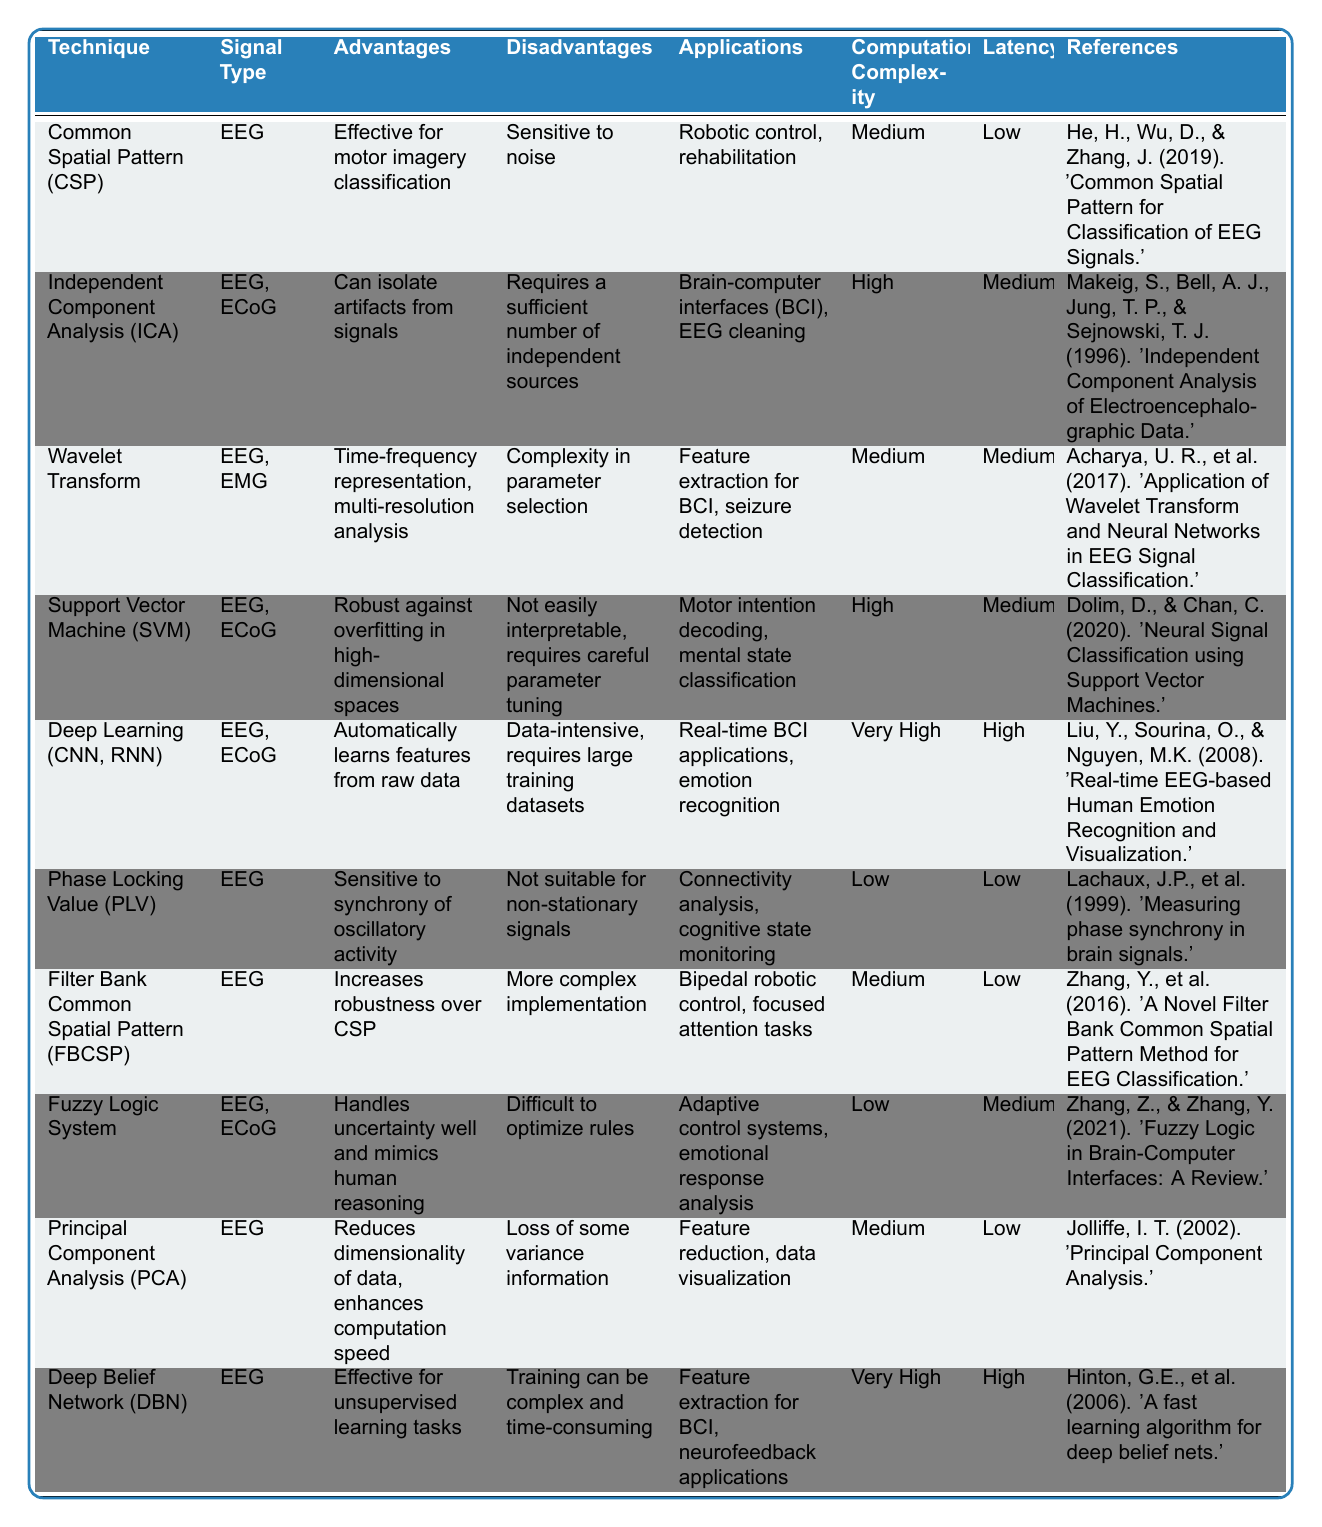What technique is effective for motor imagery classification? The table lists the "Common Spatial Pattern (CSP)" under the Advantages column for its effectiveness in motor imagery classification.
Answer: Common Spatial Pattern (CSP) Which technique has the lowest computational complexity? The table shows that "Phase Locking Value (PLV)" and "Fuzzy Logic System" are the techniques with the lowest computational complexity, both listed as Low.
Answer: Phase Locking Value (PLV), Fuzzy Logic System Is the Independent Component Analysis (ICA) suitable for EEG signals only? The table indicates that ICA can process both EEG and ECoG signal types, so it is not limited to EEG signals only.
Answer: No What are the applications of the Deep Learning technique? According to the table, Deep Learning techniques are used in real-time BCI applications and emotion recognition.
Answer: Real-time BCI applications, emotion recognition Which techniques have low latency? The table lists the techniques with low latency as Common Spatial Pattern (CSP), Phase Locking Value (PLV), Filter Bank Common Spatial Pattern (FBCSP), and Principal Component Analysis (PCA).
Answer: Common Spatial Pattern (CSP), Phase Locking Value (PLV), Filter Bank Common Spatial Pattern (FBCSP), Principal Component Analysis (PCA) Which two techniques have very high computational complexity? The table specifies that the techniques with very high computational complexity are Deep Learning and Deep Belief Network (DBN).
Answer: Deep Learning, Deep Belief Network (DBN) What is the main disadvantage of using Deep Learning techniques? The table states that the main disadvantage of Deep Learning techniques is that they are data-intensive and require large training datasets, which may hinder their application.
Answer: Data-intensive, requires large training datasets Compare the latency of Wavelet Transform and Support Vector Machine (SVM). The latency for Wavelet Transform is Medium, while for SVM, it is also Medium, indicating both techniques have similar latency levels.
Answer: Both have Medium latency Which signal type is common to all techniques listed in the table? By examining the signal types listed, EEG appears in almost all techniques, confirming it as the most common signal type.
Answer: EEG What is the reference for the Filter Bank Common Spatial Pattern (FBCSP)? The table cites the reference for FBCSP as Zhang, Y., et al. (2016). 'A Novel Filter Bank Common Spatial Pattern Method for EEG Classification.'
Answer: Zhang, Y., et al. (2016). 'A Novel Filter Bank Common Spatial Pattern Method for EEG Classification.' 